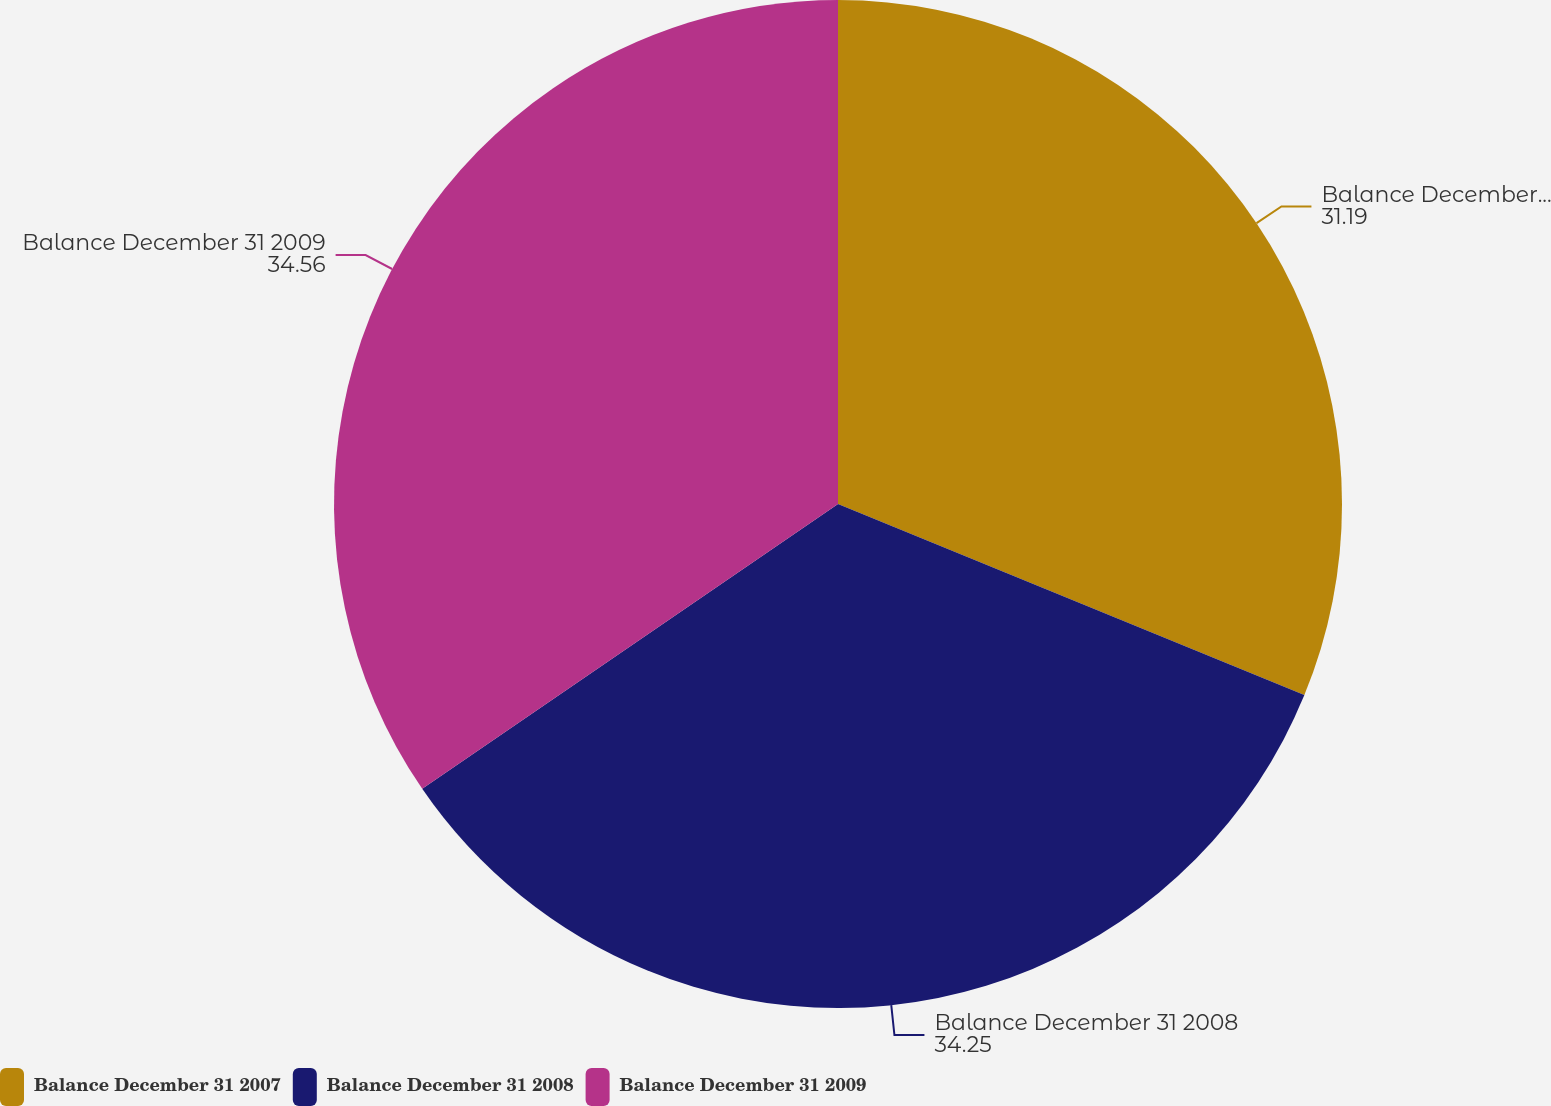Convert chart. <chart><loc_0><loc_0><loc_500><loc_500><pie_chart><fcel>Balance December 31 2007<fcel>Balance December 31 2008<fcel>Balance December 31 2009<nl><fcel>31.19%<fcel>34.25%<fcel>34.56%<nl></chart> 